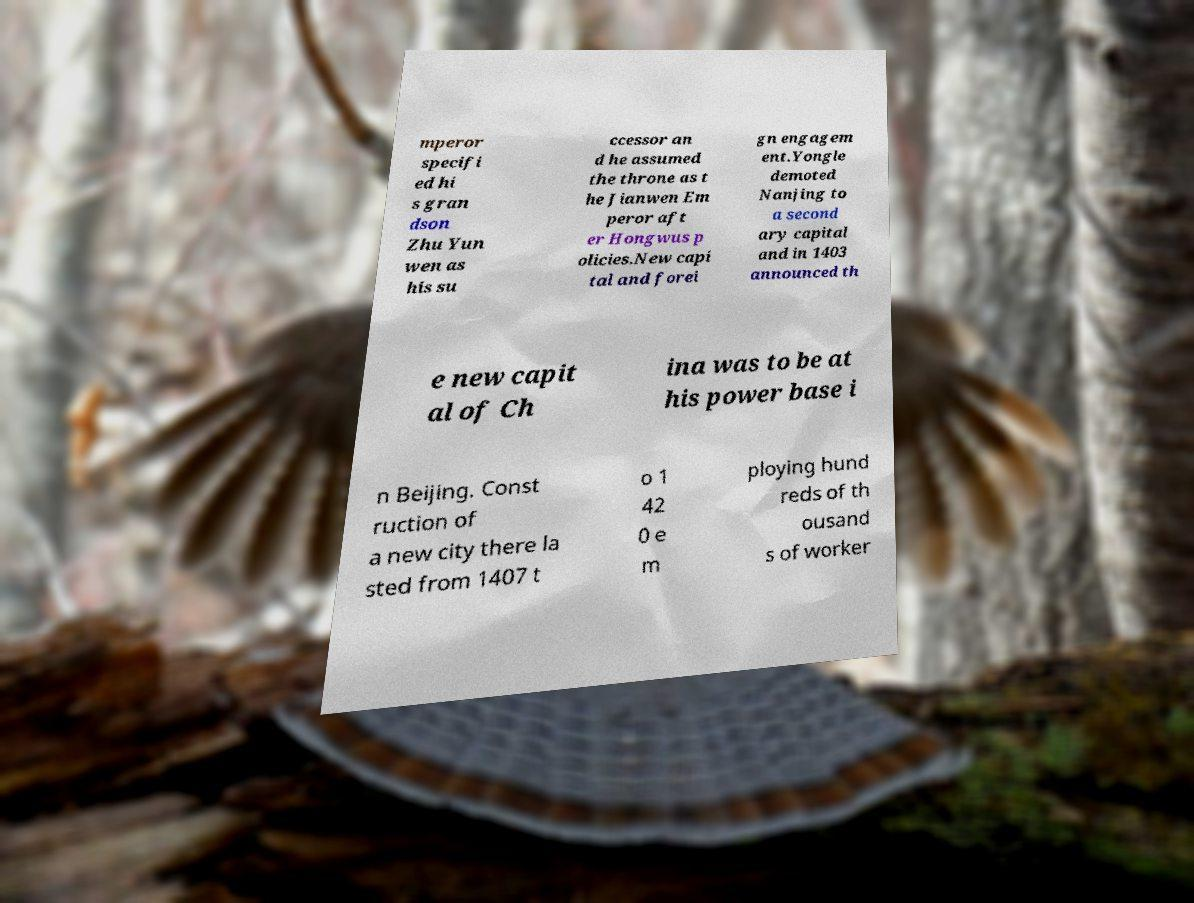Could you assist in decoding the text presented in this image and type it out clearly? mperor specifi ed hi s gran dson Zhu Yun wen as his su ccessor an d he assumed the throne as t he Jianwen Em peror aft er Hongwus p olicies.New capi tal and forei gn engagem ent.Yongle demoted Nanjing to a second ary capital and in 1403 announced th e new capit al of Ch ina was to be at his power base i n Beijing. Const ruction of a new city there la sted from 1407 t o 1 42 0 e m ploying hund reds of th ousand s of worker 